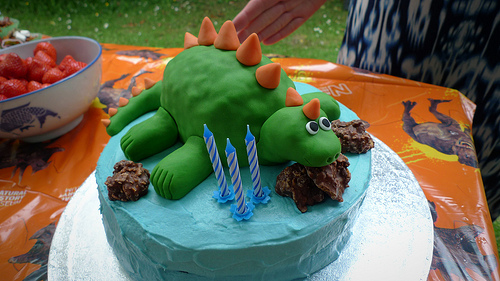<image>
Can you confirm if the dinosaur is on the chocolate? Yes. Looking at the image, I can see the dinosaur is positioned on top of the chocolate, with the chocolate providing support. Is the dinosaur on the cake? Yes. Looking at the image, I can see the dinosaur is positioned on top of the cake, with the cake providing support. Where is the dinosaur in relation to the candles? Is it next to the candles? Yes. The dinosaur is positioned adjacent to the candles, located nearby in the same general area. 